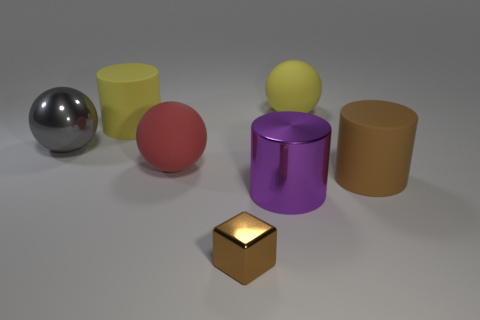Add 2 small things. How many objects exist? 9 Subtract all balls. How many objects are left? 4 Add 4 small purple things. How many small purple things exist? 4 Subtract 1 brown cylinders. How many objects are left? 6 Subtract all large yellow rubber cylinders. Subtract all big brown cylinders. How many objects are left? 5 Add 6 metal things. How many metal things are left? 9 